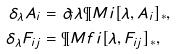<formula> <loc_0><loc_0><loc_500><loc_500>\delta _ { \lambda } A _ { i } & = \partial _ { i } \lambda \P M i [ \lambda , A _ { i } ] _ { * } , \\ \delta _ { \lambda } F _ { i j } & = \P M f i [ \lambda , F _ { i j } ] _ { * } ,</formula> 